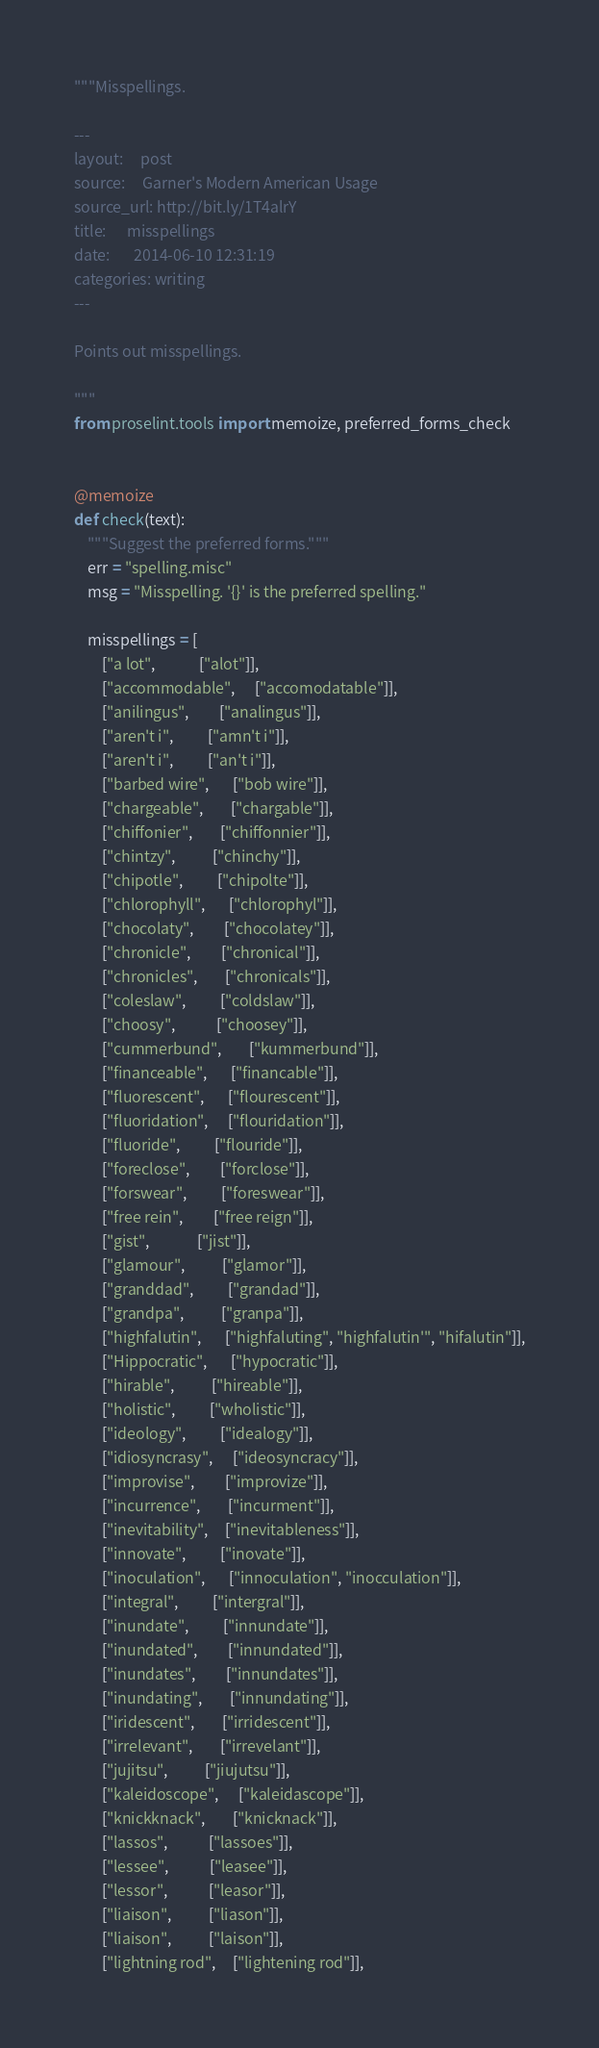<code> <loc_0><loc_0><loc_500><loc_500><_Python_>"""Misspellings.

---
layout:     post
source:     Garner's Modern American Usage
source_url: http://bit.ly/1T4alrY
title:      misspellings
date:       2014-06-10 12:31:19
categories: writing
---

Points out misspellings.

"""
from proselint.tools import memoize, preferred_forms_check


@memoize
def check(text):
    """Suggest the preferred forms."""
    err = "spelling.misc"
    msg = "Misspelling. '{}' is the preferred spelling."

    misspellings = [
        ["a lot",             ["alot"]],
        ["accommodable",      ["accomodatable"]],
        ["anilingus",         ["analingus"]],
        ["aren't i",          ["amn't i"]],
        ["aren't i",          ["an't i"]],
        ["barbed wire",       ["bob wire"]],
        ["chargeable",        ["chargable"]],
        ["chiffonier",        ["chiffonnier"]],
        ["chintzy",           ["chinchy"]],
        ["chipotle",          ["chipolte"]],
        ["chlorophyll",       ["chlorophyl"]],
        ["chocolaty",         ["chocolatey"]],
        ["chronicle",         ["chronical"]],
        ["chronicles",        ["chronicals"]],
        ["coleslaw",          ["coldslaw"]],
        ["choosy",            ["choosey"]],
        ["cummerbund",        ["kummerbund"]],
        ["financeable",       ["financable"]],
        ["fluorescent",       ["flourescent"]],
        ["fluoridation",      ["flouridation"]],
        ["fluoride",          ["flouride"]],
        ["foreclose",         ["forclose"]],
        ["forswear",          ["foreswear"]],
        ["free rein",         ["free reign"]],
        ["gist",              ["jist"]],
        ["glamour",           ["glamor"]],
        ["granddad",          ["grandad"]],
        ["grandpa",           ["granpa"]],
        ["highfalutin",       ["highfaluting", "highfalutin'", "hifalutin"]],
        ["Hippocratic",       ["hypocratic"]],
        ["hirable",           ["hireable"]],
        ["holistic",          ["wholistic"]],
        ["ideology",          ["idealogy"]],
        ["idiosyncrasy",      ["ideosyncracy"]],
        ["improvise",         ["improvize"]],
        ["incurrence",        ["incurment"]],
        ["inevitability",     ["inevitableness"]],
        ["innovate",          ["inovate"]],
        ["inoculation",       ["innoculation", "inocculation"]],
        ["integral",          ["intergral"]],
        ["inundate",          ["innundate"]],
        ["inundated",         ["innundated"]],
        ["inundates",         ["innundates"]],
        ["inundating",        ["innundating"]],
        ["iridescent",        ["irridescent"]],
        ["irrelevant",        ["irrevelant"]],
        ["jujitsu",           ["jiujutsu"]],
        ["kaleidoscope",      ["kaleidascope"]],
        ["knickknack",        ["knicknack"]],
        ["lassos",            ["lassoes"]],
        ["lessee",            ["leasee"]],
        ["lessor",            ["leasor"]],
        ["liaison",           ["liason"]],
        ["liaison",           ["laison"]],
        ["lightning rod",     ["lightening rod"]],</code> 